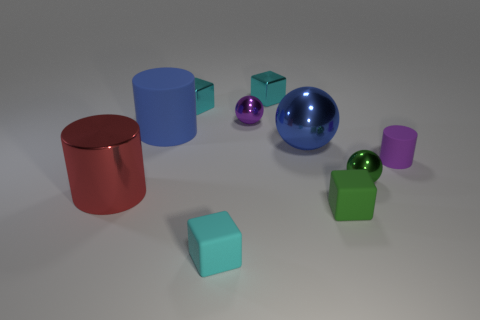What is the size of the thing that is the same color as the big matte cylinder?
Keep it short and to the point. Large. What number of other things are the same shape as the small green matte thing?
Offer a terse response. 3. Is the number of metallic balls in front of the big blue metal sphere less than the number of large purple balls?
Keep it short and to the point. No. There is a blue ball; what number of small cyan rubber blocks are behind it?
Provide a succinct answer. 0. Is the shape of the large blue object that is to the left of the purple ball the same as the green object in front of the large metallic cylinder?
Keep it short and to the point. No. What is the shape of the matte thing that is on the left side of the big metal ball and in front of the purple matte cylinder?
Make the answer very short. Cube. There is a cyan thing that is the same material as the small cylinder; what is its size?
Provide a short and direct response. Small. Is the number of small purple cylinders less than the number of small gray metal blocks?
Make the answer very short. No. There is a blue object that is to the left of the tiny cyan block in front of the small purple thing in front of the blue ball; what is its material?
Ensure brevity in your answer.  Rubber. Is the material of the tiny purple sphere behind the large blue ball the same as the thing right of the tiny green ball?
Make the answer very short. No. 